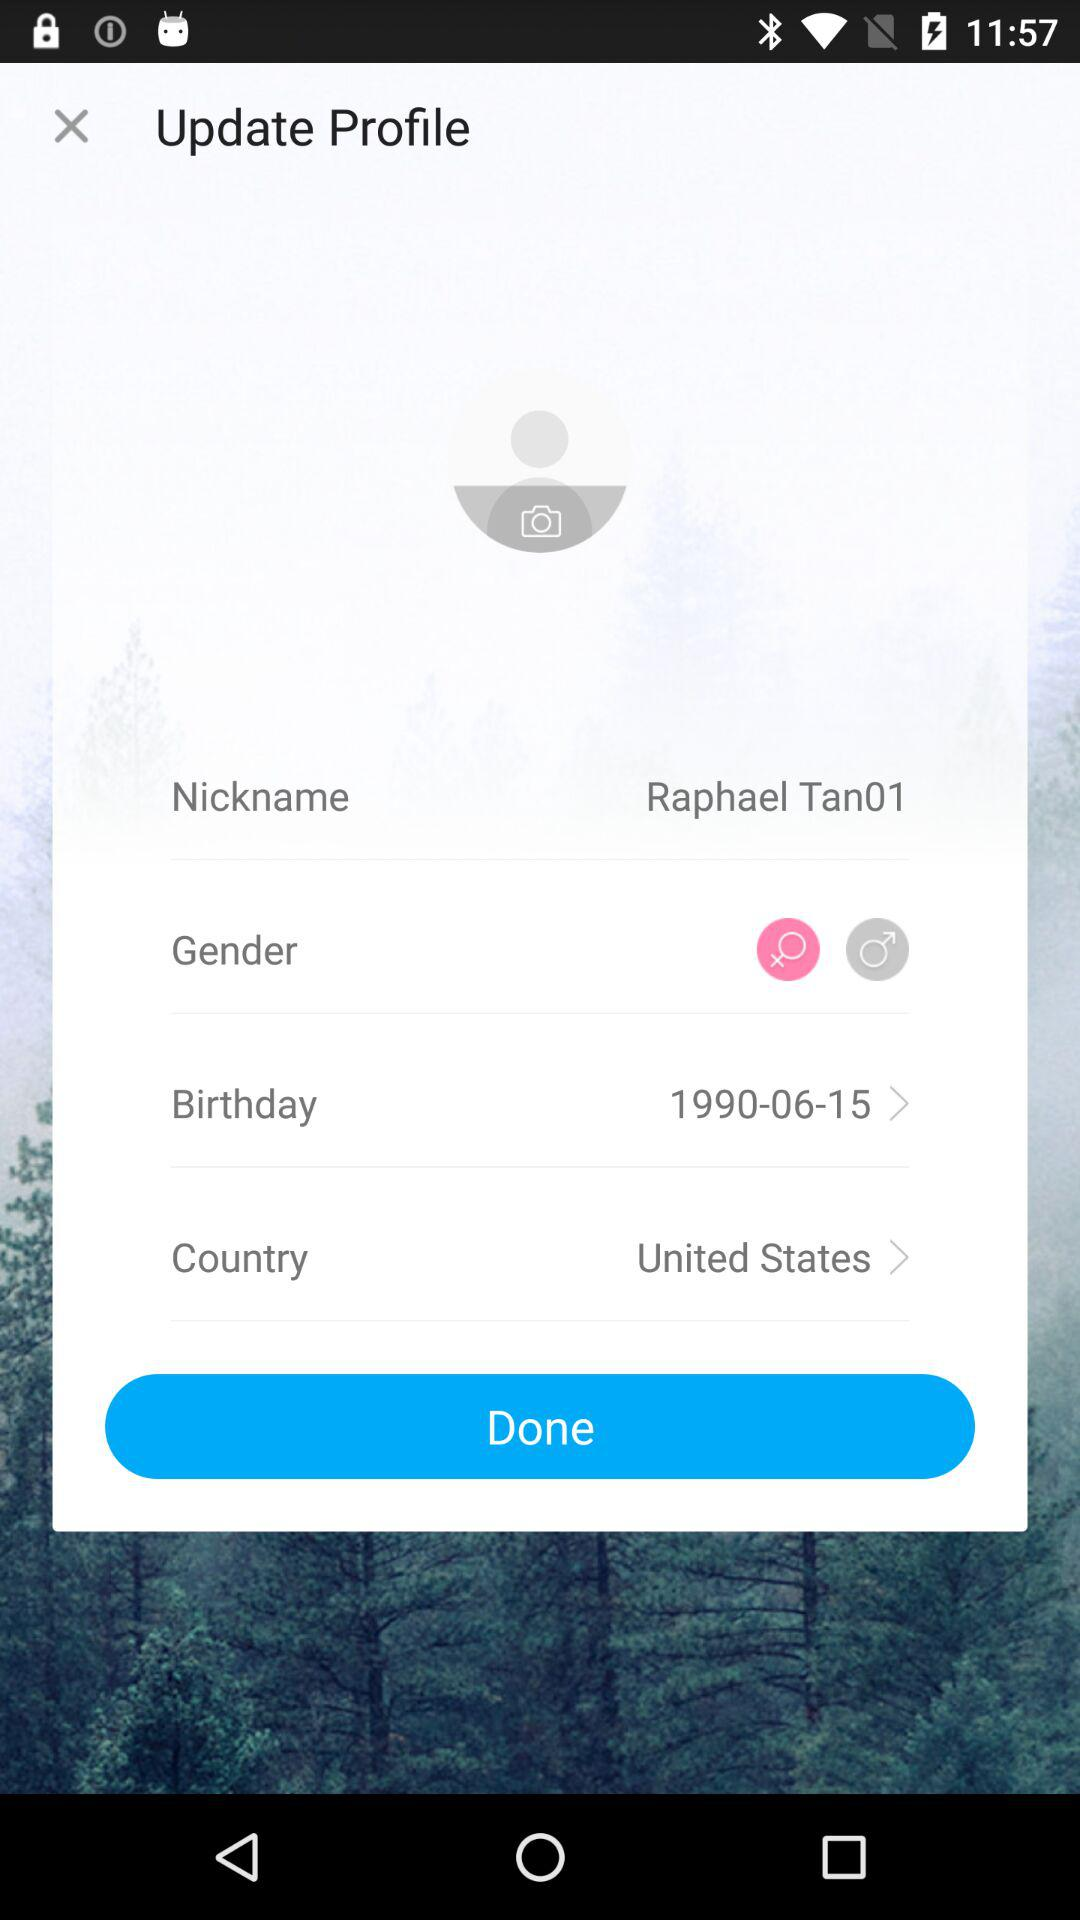What is the nickname? The nickname is "Raphael Tan01". 